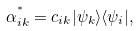Convert formula to latex. <formula><loc_0><loc_0><loc_500><loc_500>\alpha _ { i k } ^ { ^ { * } } = c _ { i k } | \psi _ { k } \rangle \langle \psi _ { i } | ,</formula> 